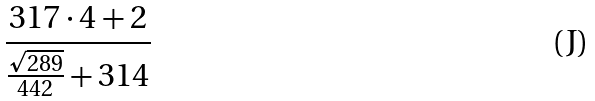Convert formula to latex. <formula><loc_0><loc_0><loc_500><loc_500>\frac { 3 1 7 \cdot 4 + 2 } { \frac { \sqrt { 2 8 9 } } { 4 4 2 } + 3 1 4 }</formula> 